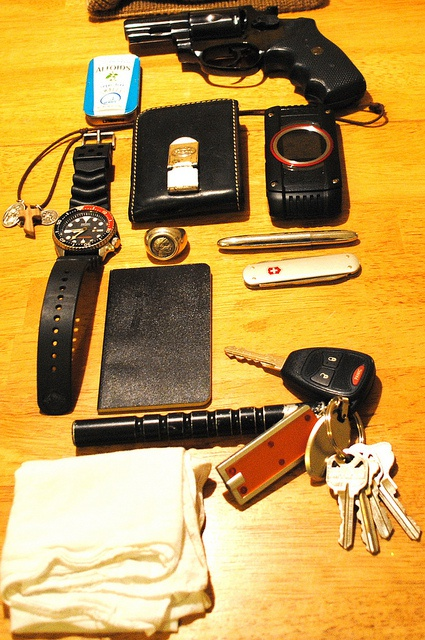Describe the objects in this image and their specific colors. I can see cell phone in orange, black, maroon, brown, and gray tones, cell phone in orange, white, lightblue, maroon, and black tones, and knife in orange, lightyellow, and khaki tones in this image. 